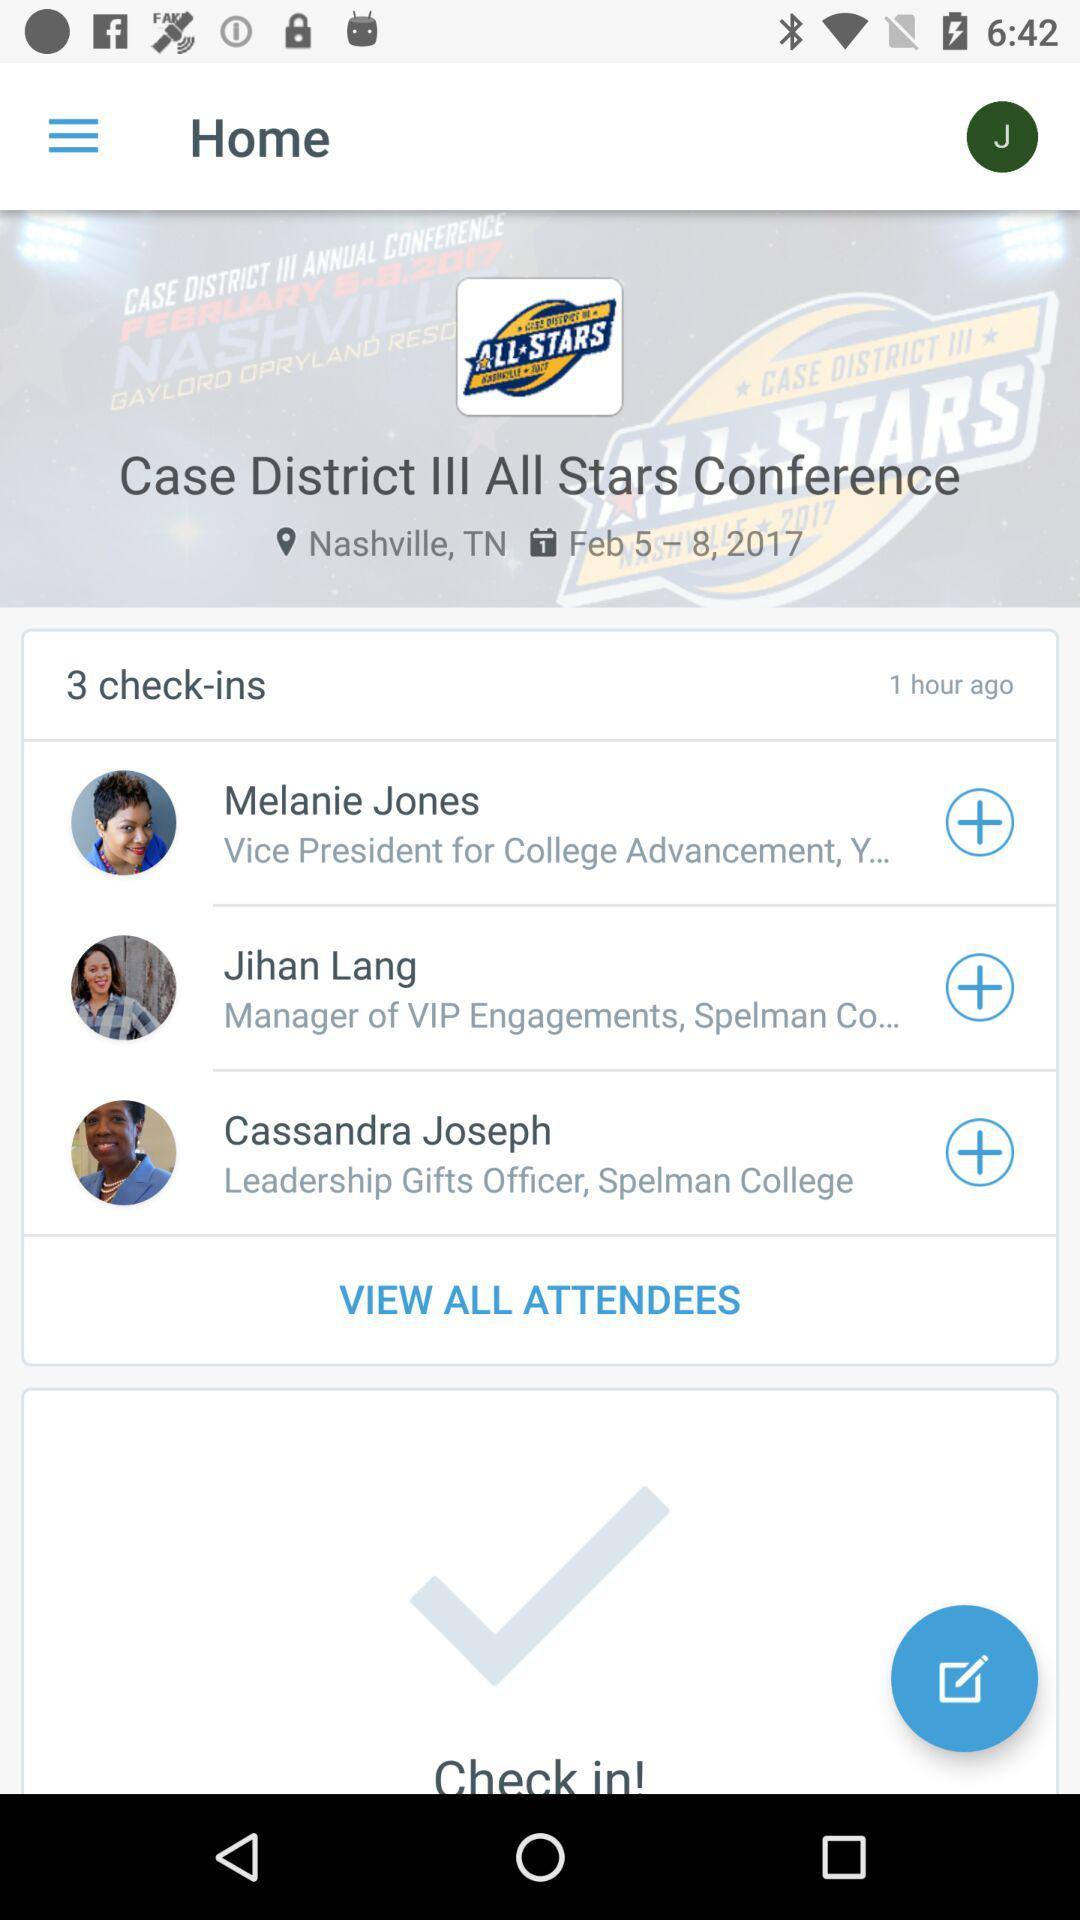How many check-ins are there in total?
Answer the question using a single word or phrase. 3 